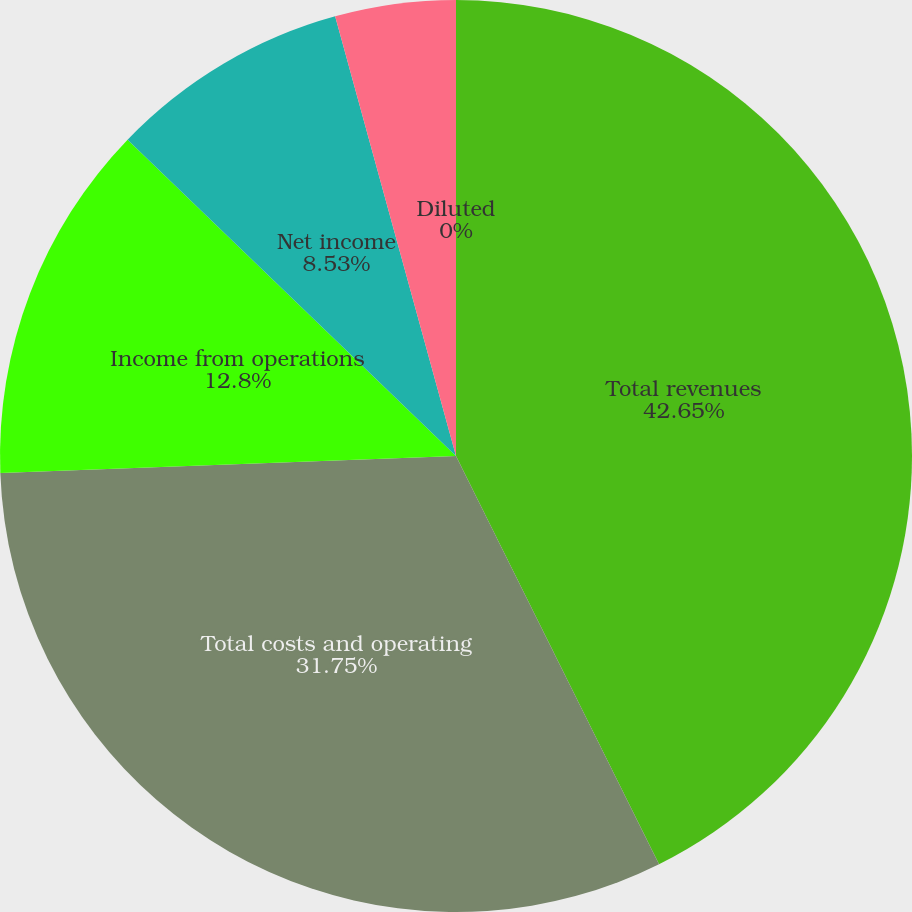Convert chart. <chart><loc_0><loc_0><loc_500><loc_500><pie_chart><fcel>Total revenues<fcel>Total costs and operating<fcel>Income from operations<fcel>Net income<fcel>Basic<fcel>Diluted<nl><fcel>42.66%<fcel>31.75%<fcel>12.8%<fcel>8.53%<fcel>4.27%<fcel>0.0%<nl></chart> 